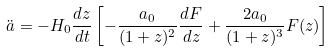Convert formula to latex. <formula><loc_0><loc_0><loc_500><loc_500>\ddot { a } = - H _ { 0 } \frac { d z } { d t } \left [ - \frac { a _ { 0 } } { ( 1 + z ) ^ { 2 } } \frac { d F } { d z } + \frac { 2 a _ { 0 } } { ( 1 + z ) ^ { 3 } } F ( z ) \right ]</formula> 